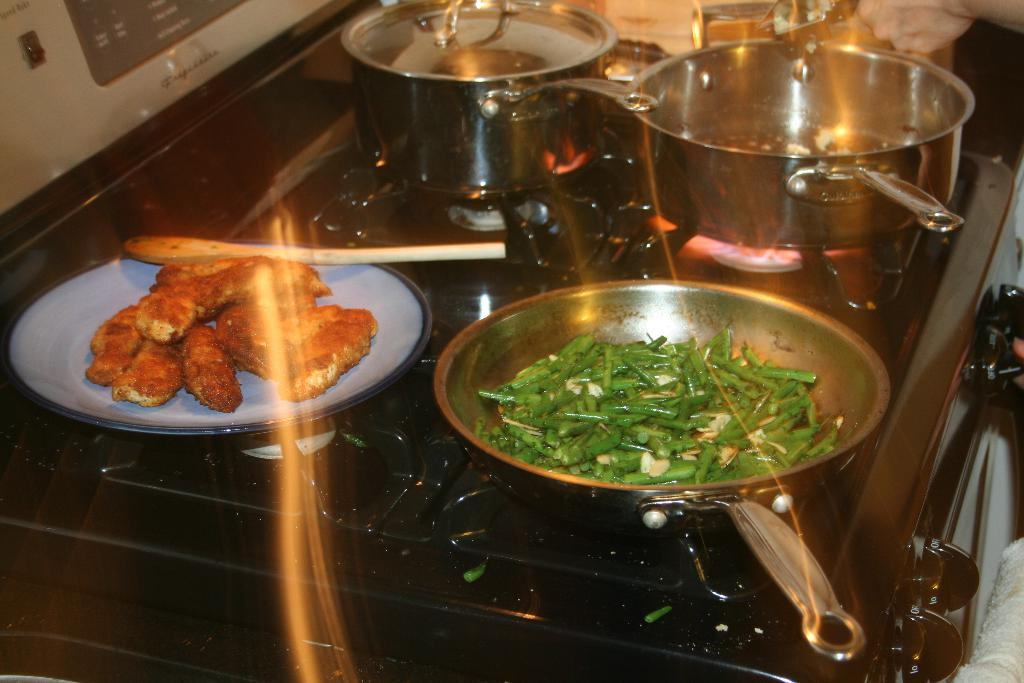What type of appliance can be seen in the image? There is a stove in the image. What are the containers used for holding food in the image? There are bowls in the image. What is the food item placed on in the image? There is a plate with a food item in the image. Whose hand is visible in the image? A person's hand is present in the image. How many dimes are visible on the stove in the image? There are no dimes visible on the stove in the image. What type of coil is present in the image? There is no coil present in the image. 